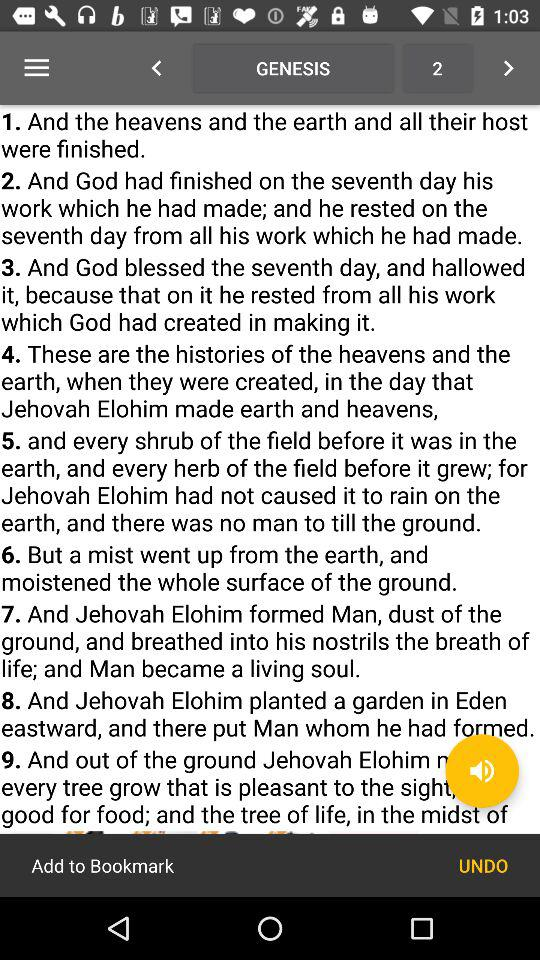When did God finish his work? God finished his work on the seventh day. 